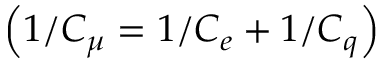Convert formula to latex. <formula><loc_0><loc_0><loc_500><loc_500>\left ( 1 / C _ { \mu } = 1 / C _ { e } + 1 / C _ { q } \right )</formula> 